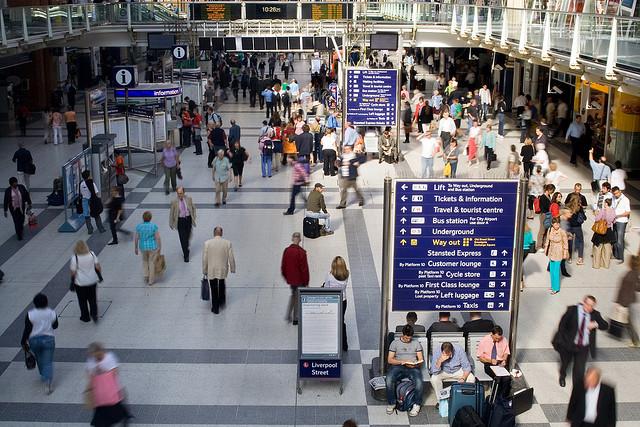On the sign, which is the direction for the customer lounge?
Short answer required. Right. What does the I over the desks?
Short answer required. Information. Where is this?
Give a very brief answer. Airport. Is the image taken at the airport?
Concise answer only. Yes. 